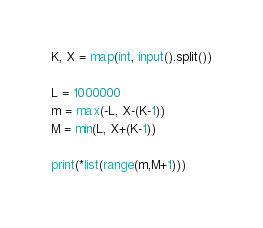<code> <loc_0><loc_0><loc_500><loc_500><_Python_>K, X = map(int, input().split())

L = 1000000
m = max(-L, X-(K-1))
M = min(L, X+(K-1))

print(*list(range(m,M+1)))</code> 